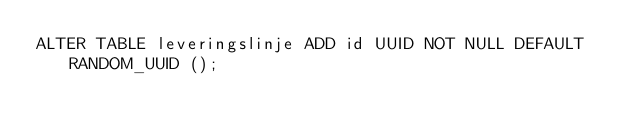Convert code to text. <code><loc_0><loc_0><loc_500><loc_500><_SQL_>ALTER TABLE leveringslinje ADD id UUID NOT NULL DEFAULT RANDOM_UUID ();</code> 